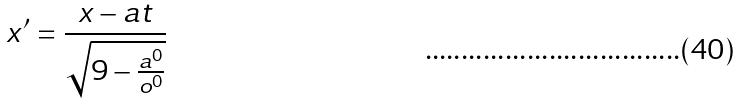<formula> <loc_0><loc_0><loc_500><loc_500>x ^ { \prime } = \frac { x - a t } { \sqrt { 9 - \frac { a ^ { 0 } } { o ^ { 0 } } } }</formula> 